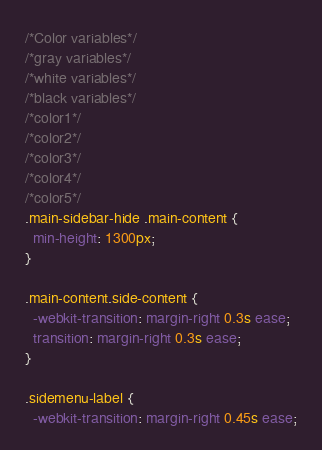Convert code to text. <code><loc_0><loc_0><loc_500><loc_500><_CSS_>/*Color variables*/
/*gray variables*/
/*white variables*/
/*black variables*/
/*color1*/
/*color2*/
/*color3*/
/*color4*/
/*color5*/
.main-sidebar-hide .main-content {
  min-height: 1300px;
}

.main-content.side-content {
  -webkit-transition: margin-right 0.3s ease;
  transition: margin-right 0.3s ease;
}

.sidemenu-label {
  -webkit-transition: margin-right 0.45s ease;</code> 